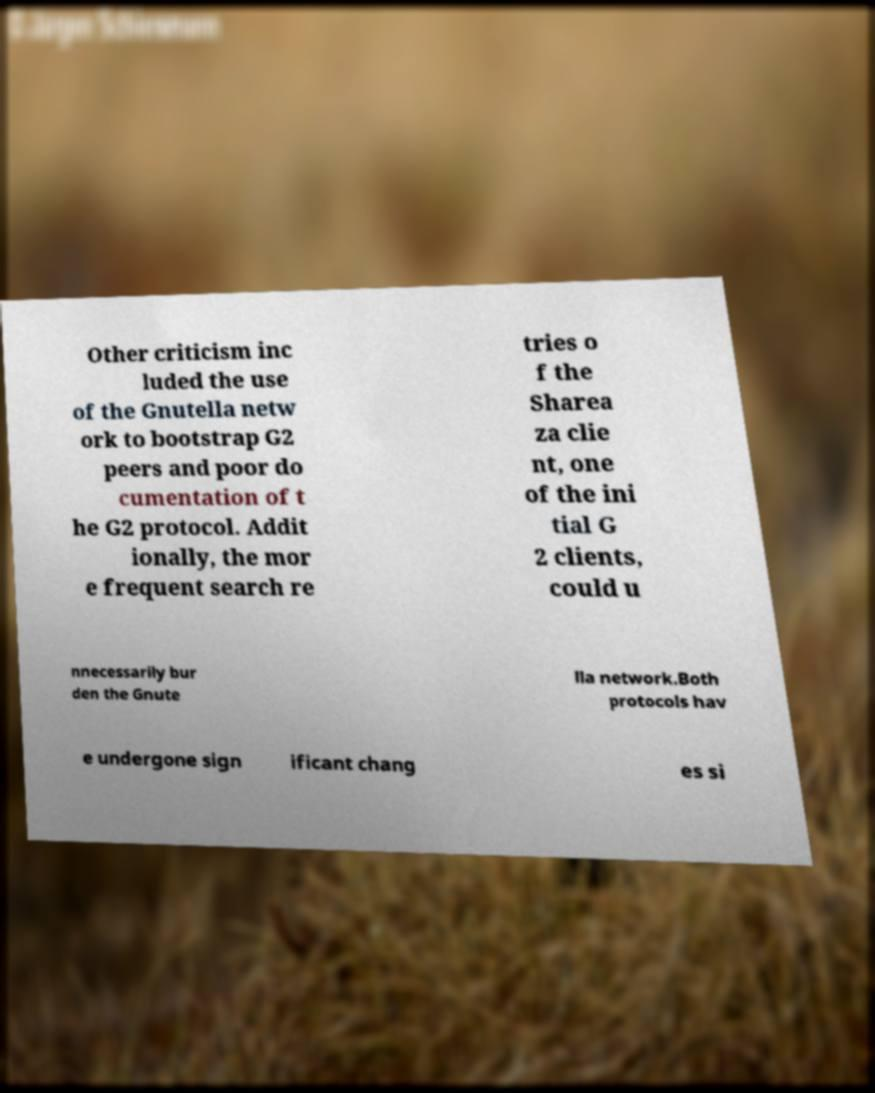Could you assist in decoding the text presented in this image and type it out clearly? Other criticism inc luded the use of the Gnutella netw ork to bootstrap G2 peers and poor do cumentation of t he G2 protocol. Addit ionally, the mor e frequent search re tries o f the Sharea za clie nt, one of the ini tial G 2 clients, could u nnecessarily bur den the Gnute lla network.Both protocols hav e undergone sign ificant chang es si 